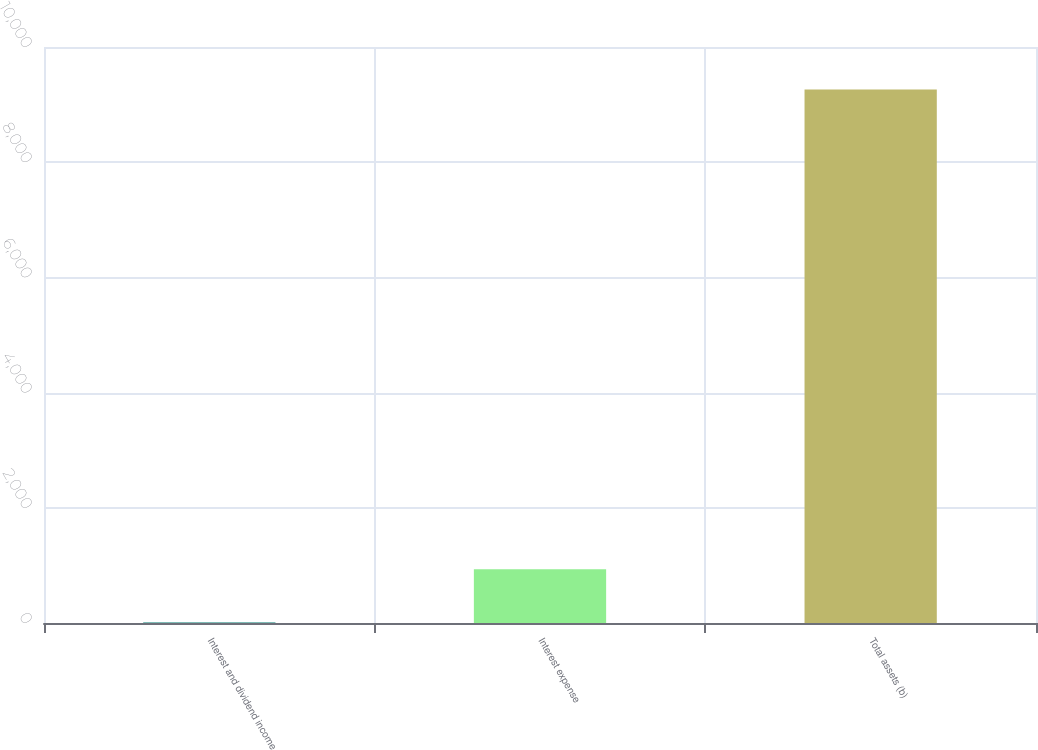Convert chart. <chart><loc_0><loc_0><loc_500><loc_500><bar_chart><fcel>Interest and dividend income<fcel>Interest expense<fcel>Total assets (b)<nl><fcel>9<fcel>934.2<fcel>9261<nl></chart> 